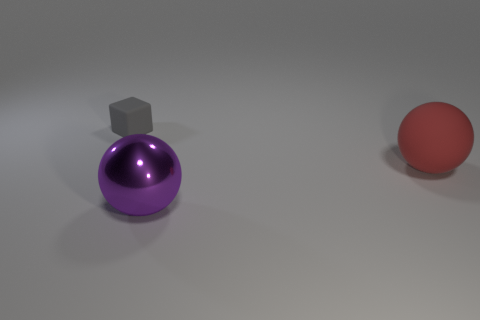Add 1 rubber balls. How many objects exist? 4 Subtract all balls. How many objects are left? 1 Subtract all rubber objects. Subtract all large gray matte cylinders. How many objects are left? 1 Add 2 large purple shiny objects. How many large purple shiny objects are left? 3 Add 3 small gray objects. How many small gray objects exist? 4 Subtract 0 yellow spheres. How many objects are left? 3 